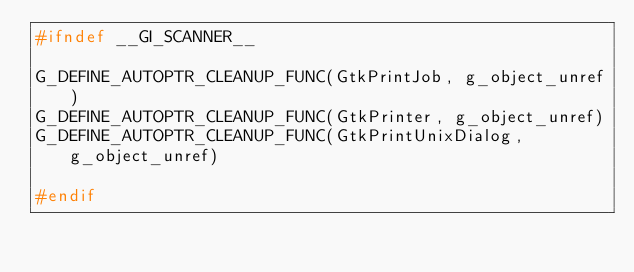<code> <loc_0><loc_0><loc_500><loc_500><_C_>#ifndef __GI_SCANNER__

G_DEFINE_AUTOPTR_CLEANUP_FUNC(GtkPrintJob, g_object_unref)
G_DEFINE_AUTOPTR_CLEANUP_FUNC(GtkPrinter, g_object_unref)
G_DEFINE_AUTOPTR_CLEANUP_FUNC(GtkPrintUnixDialog, g_object_unref)

#endif
</code> 